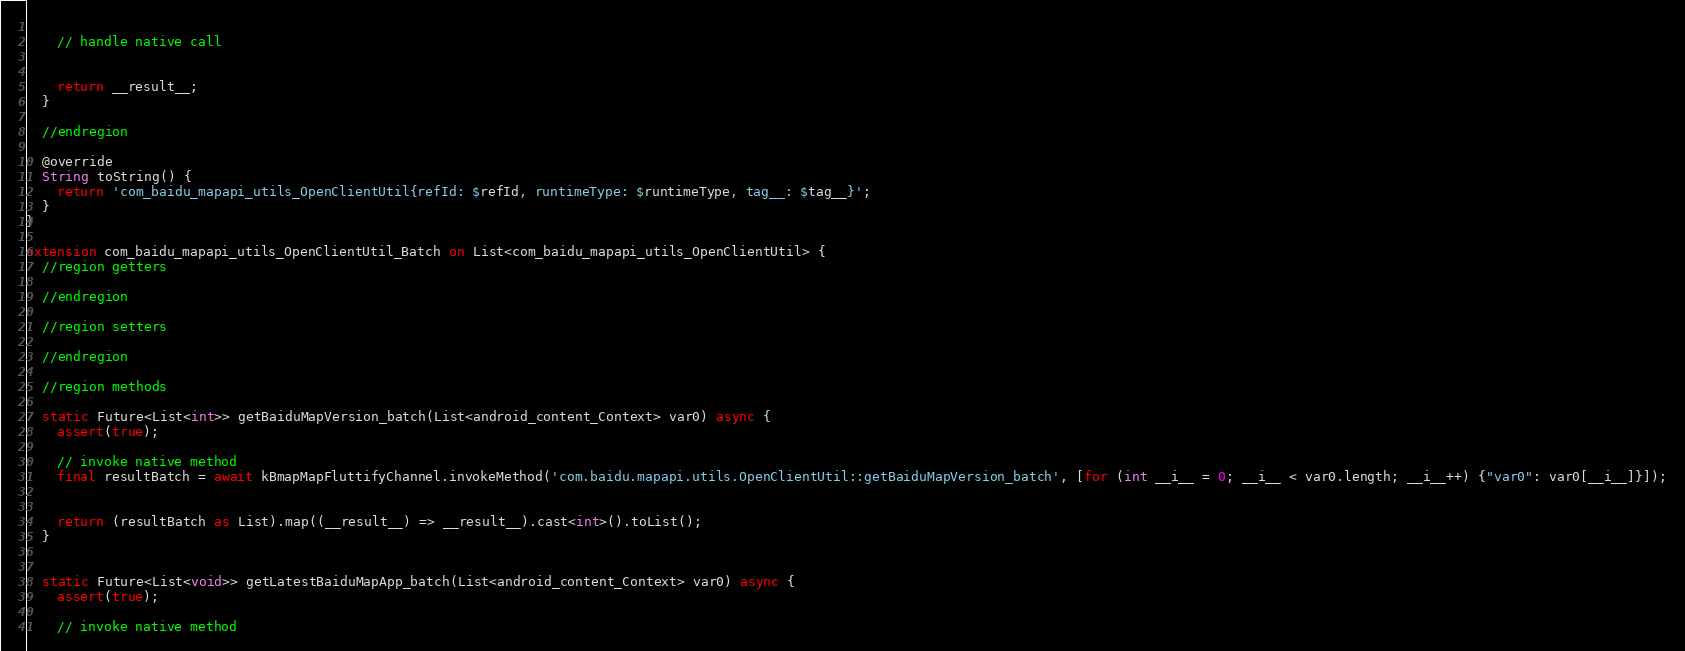Convert code to text. <code><loc_0><loc_0><loc_500><loc_500><_Dart_>  
    // handle native call
  
  
    return __result__;
  }
  
  //endregion

  @override
  String toString() {
    return 'com_baidu_mapapi_utils_OpenClientUtil{refId: $refId, runtimeType: $runtimeType, tag__: $tag__}';
  }
}

extension com_baidu_mapapi_utils_OpenClientUtil_Batch on List<com_baidu_mapapi_utils_OpenClientUtil> {
  //region getters
  
  //endregion

  //region setters
  
  //endregion

  //region methods
  
  static Future<List<int>> getBaiduMapVersion_batch(List<android_content_Context> var0) async {
    assert(true);
  
    // invoke native method
    final resultBatch = await kBmapMapFluttifyChannel.invokeMethod('com.baidu.mapapi.utils.OpenClientUtil::getBaiduMapVersion_batch', [for (int __i__ = 0; __i__ < var0.length; __i__++) {"var0": var0[__i__]}]);
  
  
    return (resultBatch as List).map((__result__) => __result__).cast<int>().toList();
  }
  
  
  static Future<List<void>> getLatestBaiduMapApp_batch(List<android_content_Context> var0) async {
    assert(true);
  
    // invoke native method</code> 